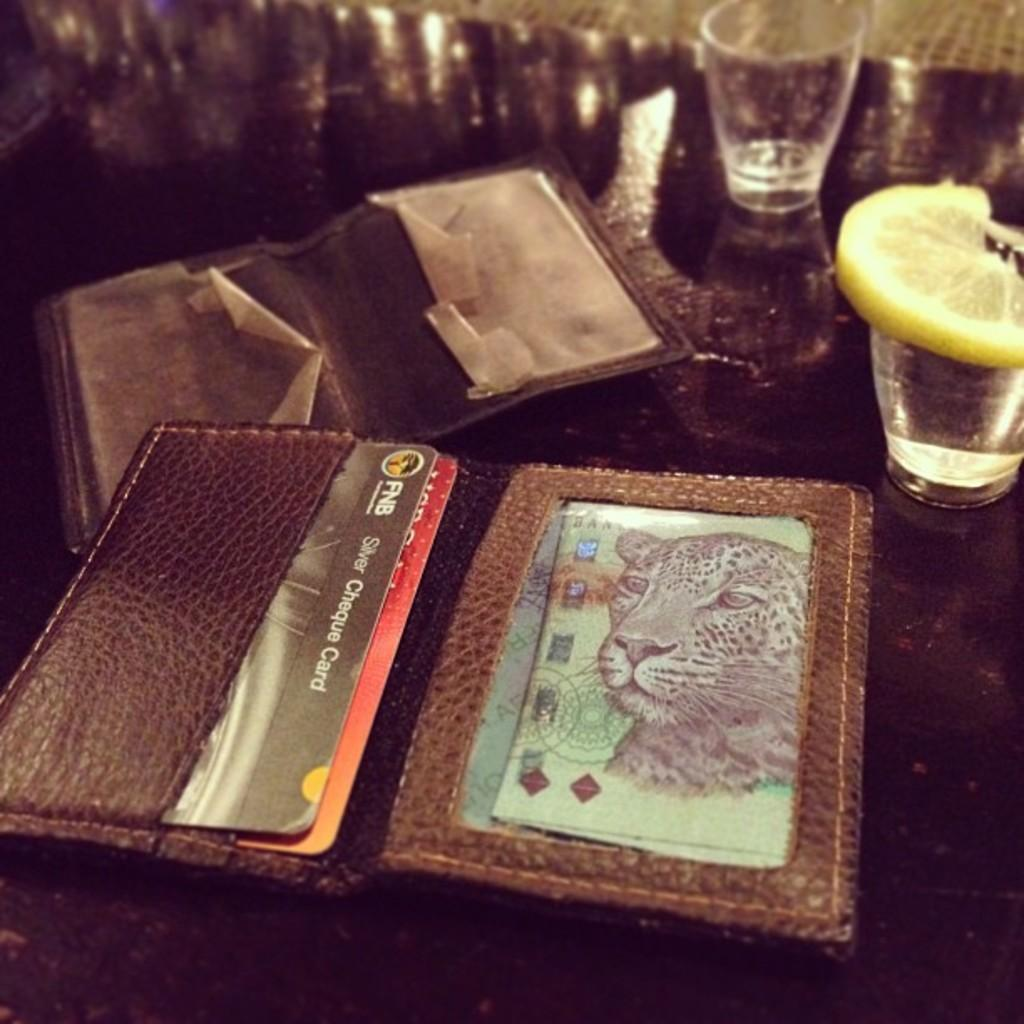<image>
Render a clear and concise summary of the photo. A black Silver Cheque card with a FNB logo. 